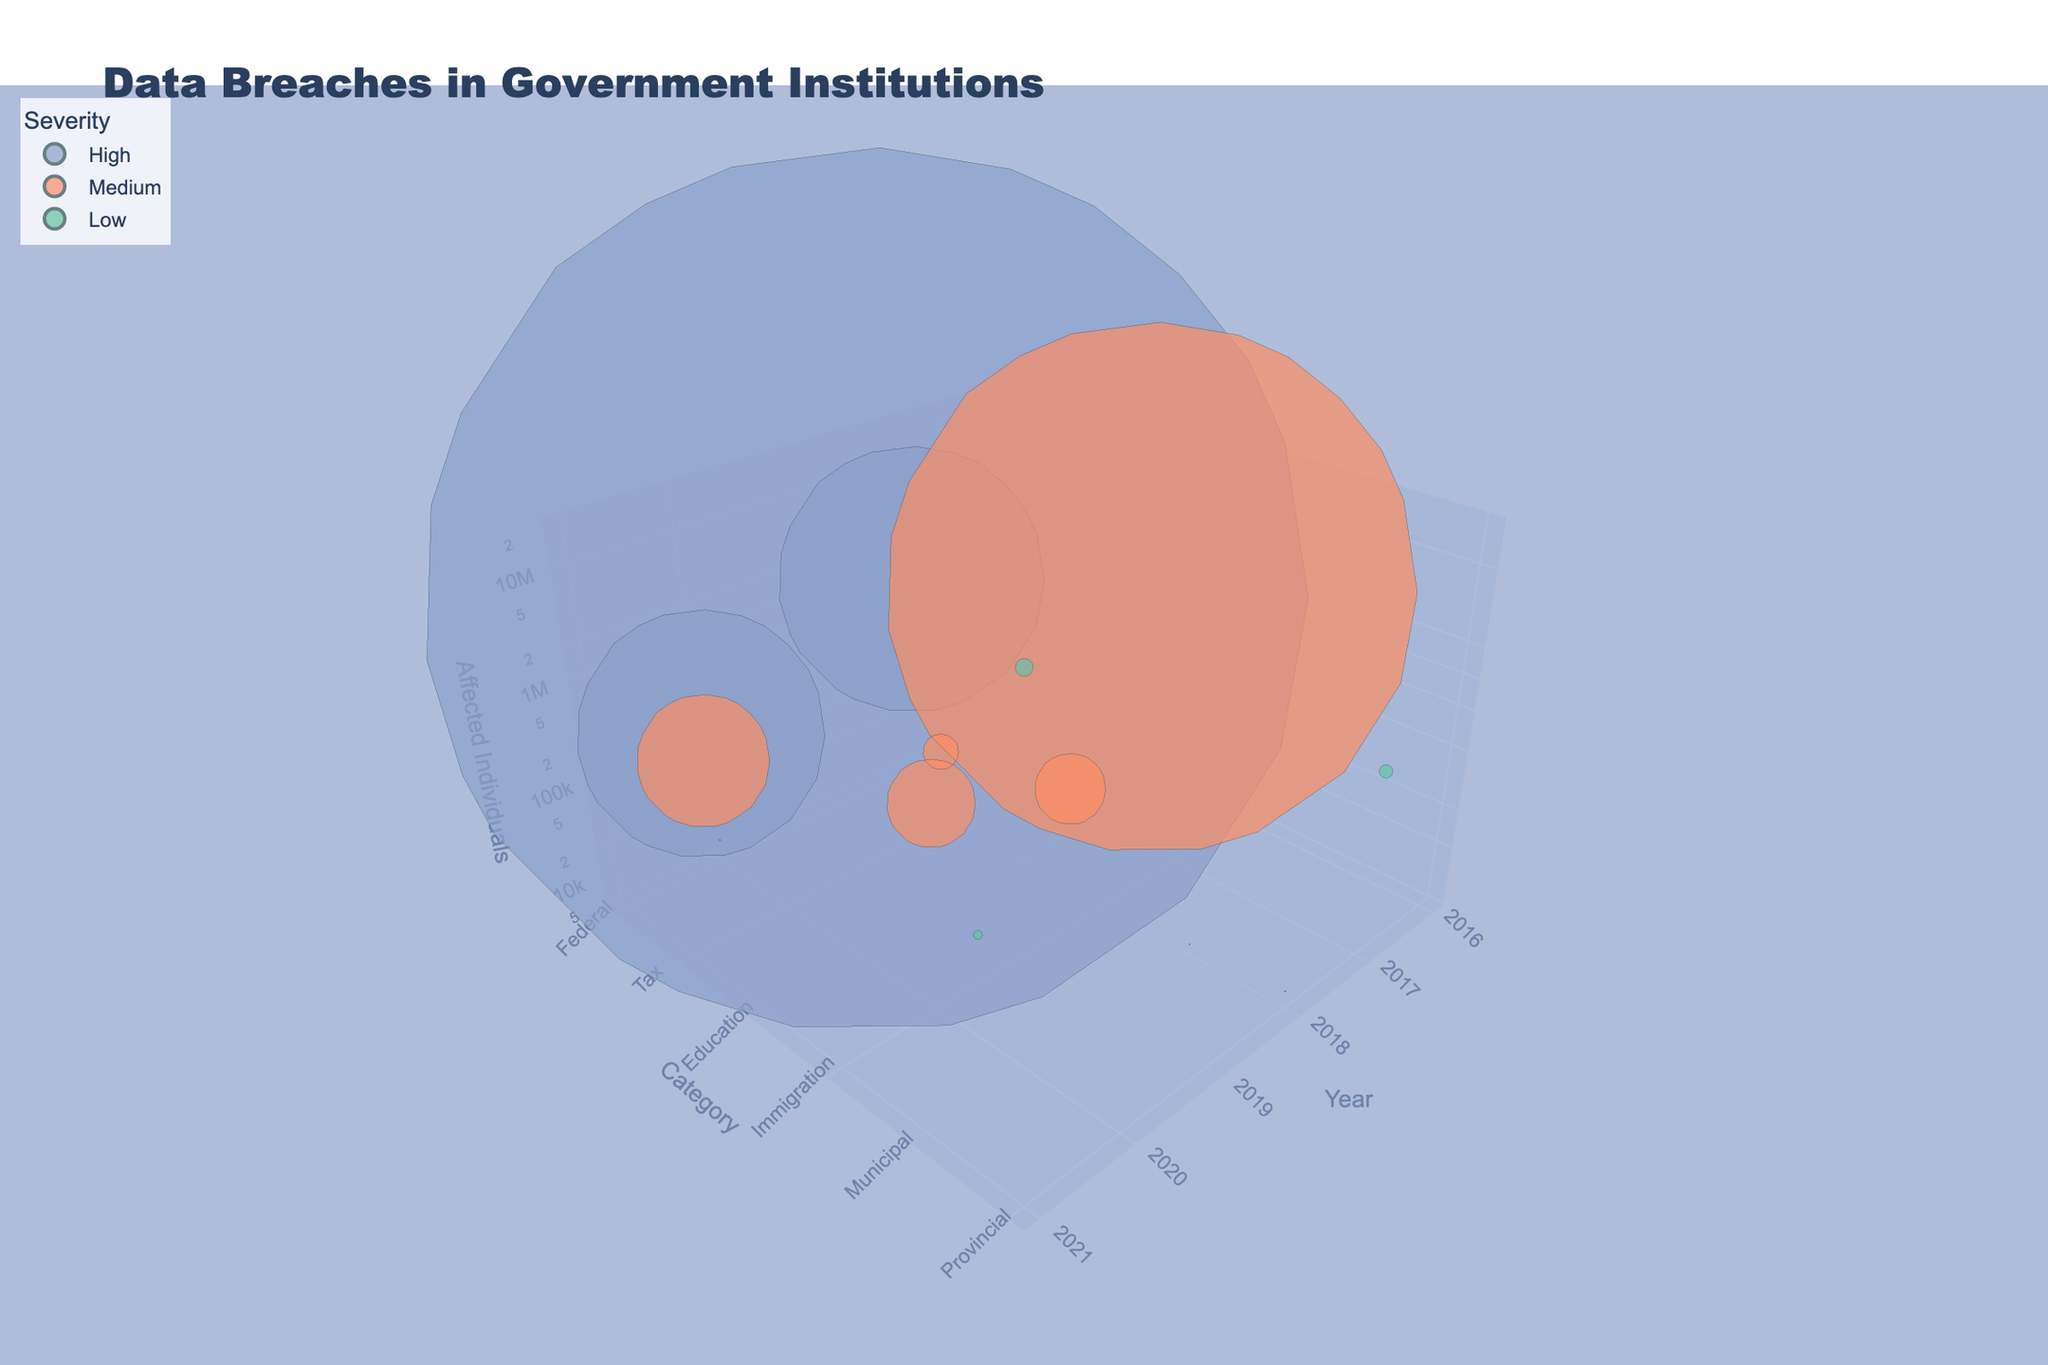How many data points are there in the figure? In total, each bubble represents one data point, and by counting the bubbles in the figure, we find there are 14 in total.
Answer: 14 Which year had the highest number of affected individuals? To determine this, identify the tallest bubble along the z-axis (Affected Individuals). The year 2016, represented by the U.S. Office of Personnel Management, has the highest at 21,500,000 affected individuals.
Answer: 2016 What category has the most data breaches with high severity? To find the category with the most high-severity breaches, look for bubbles marked with high severity and count their categories. Federal and Tax each have one high-severity breach.
Answer: Federal and Tax Which data breach in 2019 affected the most individuals? For this, locate the year 2019 and compare the height of the bubbles marked "2019." The Bulgarian National Revenue Agency had the highest at 5,000,000 affected individuals.
Answer: Bulgarian National Revenue Agency What is the median size of the data breaches in terms of affected individuals? List the affected individuals and find the median in an ordered dataset. Ordered values: 6000, 7000, 8000, 50000, 76000, 100000, 200000, 400000, 500000, 750000, 1400000, 1500000, 3000000, 21500000. The middle values are 200000 and 400000, and their average is (200000 + 400000)/2 = 300000.
Answer: 300000 Which institution had a data breach in the category of Healthcare, and how many were affected? Look for the bubble labeled Healthcare. The institution is Singapore Health Services with 1,500,000 affected individuals.
Answer: Singapore Health Services, 1,500,000 Is there a notable trend in the severity level of data breaches over the years from 2016 to 2021? Examine the distribution of high, medium, and low-severity bubbles across the years. Data breaches of varying severity levels occur each year without a clear trend toward increasing or decreasing severity.
Answer: No What's the total number of affected individuals in the category Tax? Sum the affected individuals in both Tax breaches: 5,000,000 (Bulgarian National Revenue Agency) + 100,000 (Canadian Revenue Agency) = 5,100,000.
Answer: 5,100,000 Which state institution had a high-severity data breach and in which year did it occur? Seek out high-severity bubbles in the State category. The Washington State Auditor's Office in 2021 had a high-severity breach.
Answer: Washington State Auditor's Office, 2021 